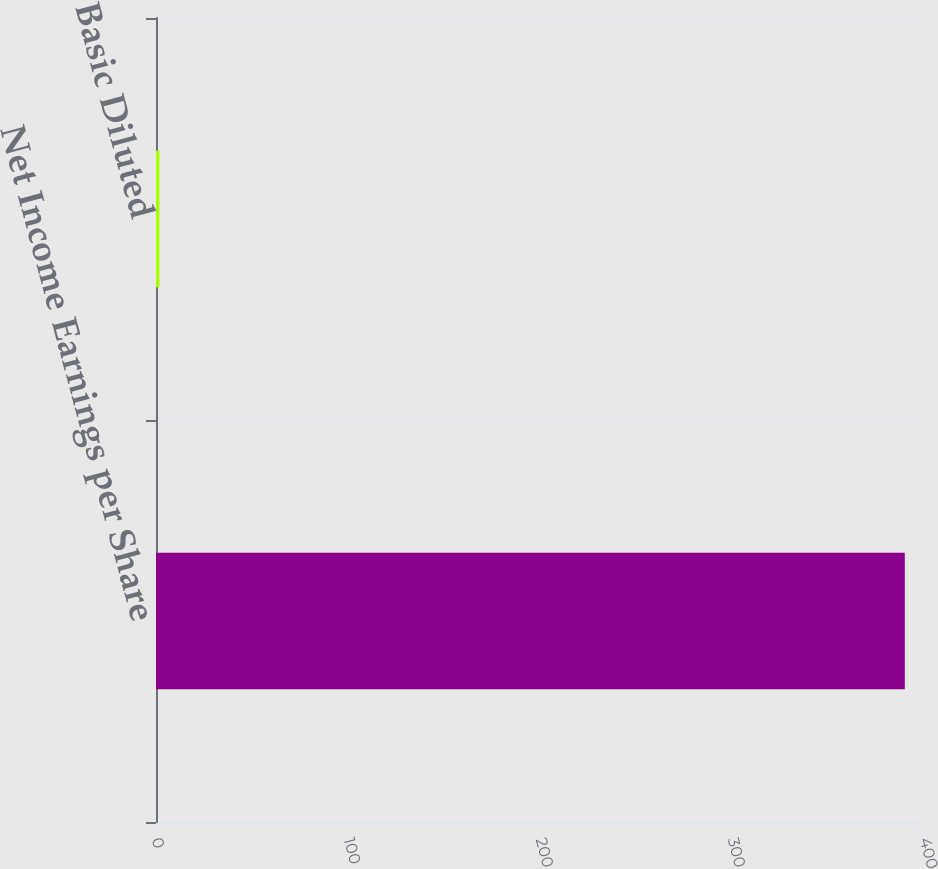<chart> <loc_0><loc_0><loc_500><loc_500><bar_chart><fcel>Net Income Earnings per Share<fcel>Basic Diluted<nl><fcel>390<fcel>1.8<nl></chart> 